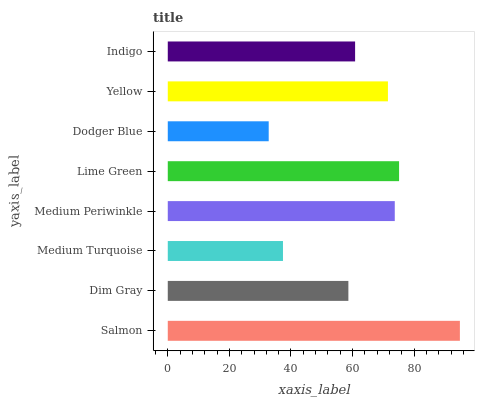Is Dodger Blue the minimum?
Answer yes or no. Yes. Is Salmon the maximum?
Answer yes or no. Yes. Is Dim Gray the minimum?
Answer yes or no. No. Is Dim Gray the maximum?
Answer yes or no. No. Is Salmon greater than Dim Gray?
Answer yes or no. Yes. Is Dim Gray less than Salmon?
Answer yes or no. Yes. Is Dim Gray greater than Salmon?
Answer yes or no. No. Is Salmon less than Dim Gray?
Answer yes or no. No. Is Yellow the high median?
Answer yes or no. Yes. Is Indigo the low median?
Answer yes or no. Yes. Is Medium Turquoise the high median?
Answer yes or no. No. Is Dodger Blue the low median?
Answer yes or no. No. 